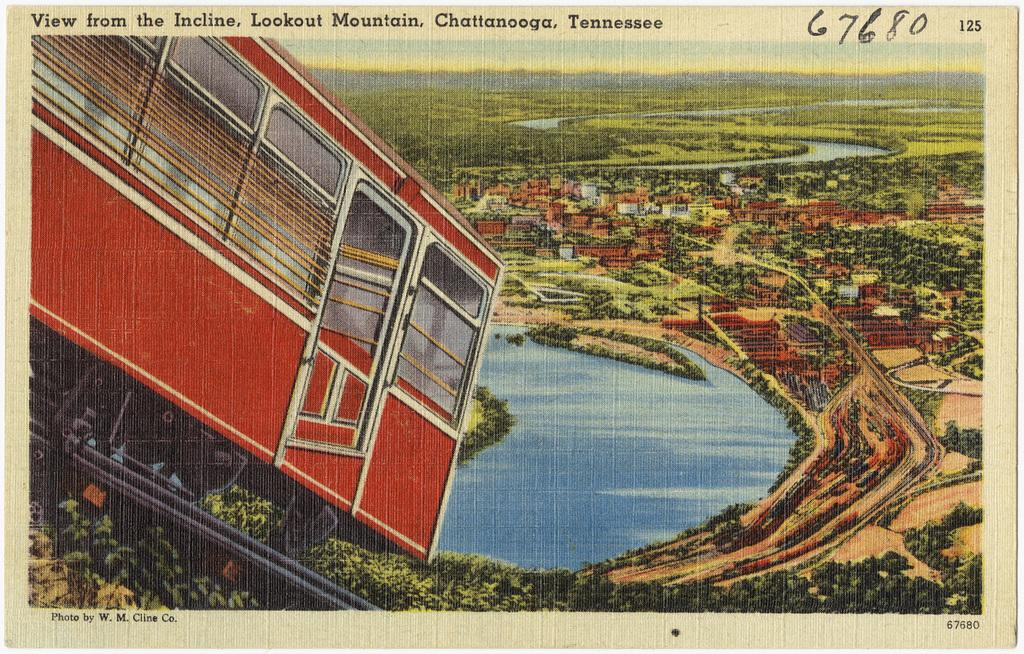<image>
Describe the image concisely. A postcard of the view from the Incline on Lookout Mountain, Chattanooga, Tennessee, has the number '67680' written on it. 